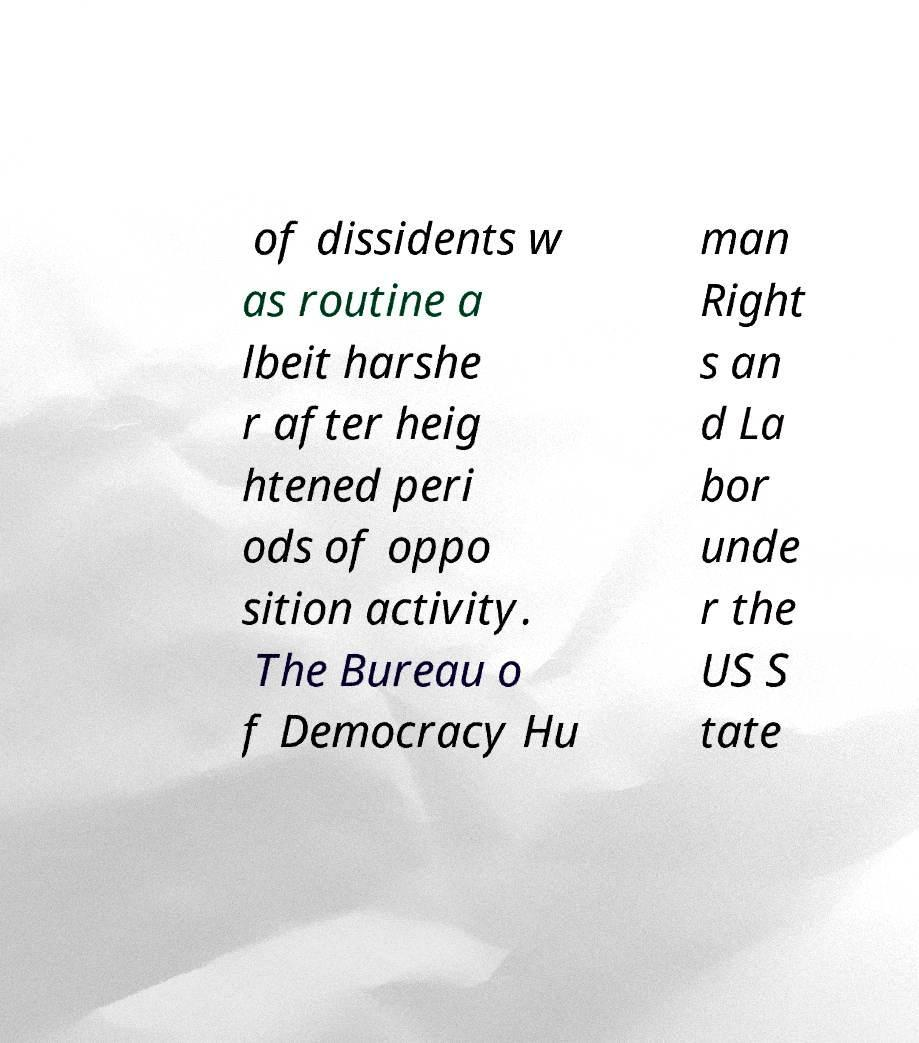Could you assist in decoding the text presented in this image and type it out clearly? of dissidents w as routine a lbeit harshe r after heig htened peri ods of oppo sition activity. The Bureau o f Democracy Hu man Right s an d La bor unde r the US S tate 